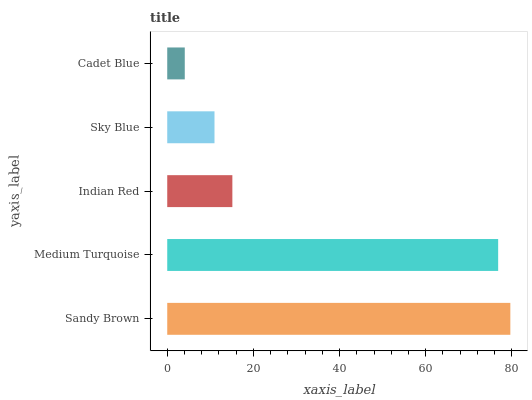Is Cadet Blue the minimum?
Answer yes or no. Yes. Is Sandy Brown the maximum?
Answer yes or no. Yes. Is Medium Turquoise the minimum?
Answer yes or no. No. Is Medium Turquoise the maximum?
Answer yes or no. No. Is Sandy Brown greater than Medium Turquoise?
Answer yes or no. Yes. Is Medium Turquoise less than Sandy Brown?
Answer yes or no. Yes. Is Medium Turquoise greater than Sandy Brown?
Answer yes or no. No. Is Sandy Brown less than Medium Turquoise?
Answer yes or no. No. Is Indian Red the high median?
Answer yes or no. Yes. Is Indian Red the low median?
Answer yes or no. Yes. Is Cadet Blue the high median?
Answer yes or no. No. Is Sky Blue the low median?
Answer yes or no. No. 